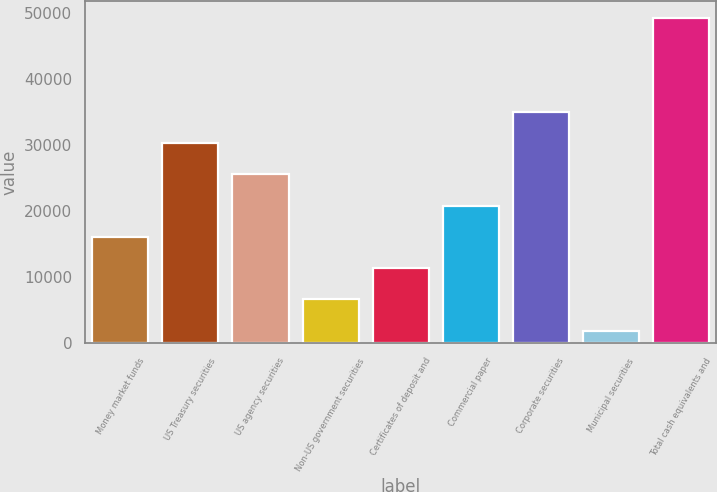Convert chart to OTSL. <chart><loc_0><loc_0><loc_500><loc_500><bar_chart><fcel>Money market funds<fcel>US Treasury securities<fcel>US agency securities<fcel>Non-US government securities<fcel>Certificates of deposit and<fcel>Commercial paper<fcel>Corporate securities<fcel>Municipal securities<fcel>Total cash equivalents and<nl><fcel>16138.2<fcel>30359.4<fcel>25619<fcel>6657.4<fcel>11397.8<fcel>20878.6<fcel>35099.8<fcel>1917<fcel>49321<nl></chart> 